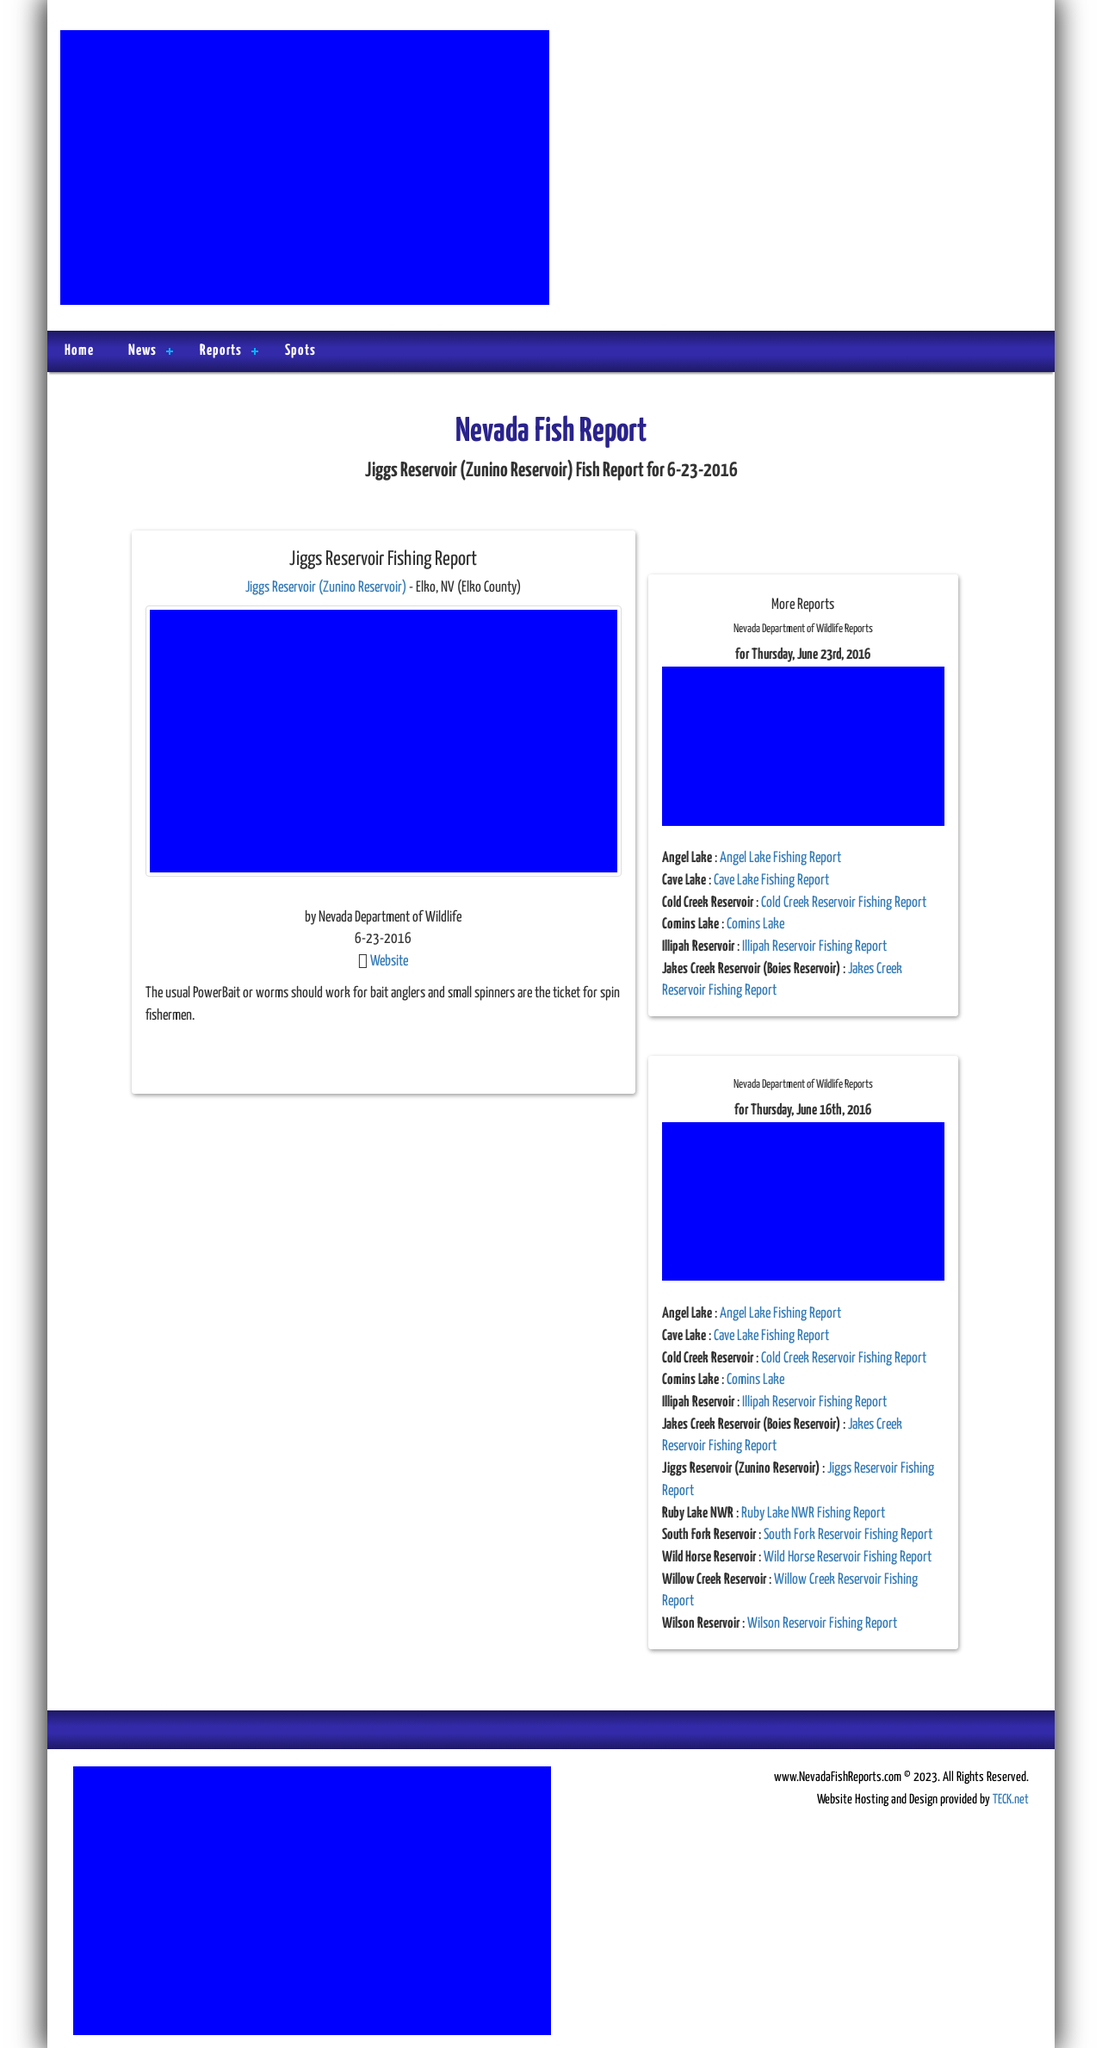What functionalities does the website provide to assist anglers? This fishing report website is designed to offer critical information beneficial to anglers, such as updated fishing conditions, bait recommendations, and location-specific pointers. Additionally, it likely features interactive elements like search functions where users can look up specific reservoirs or regions, subscription options for regular updates, and perhaps a forum or comment section where the community can share catches and experiences. 